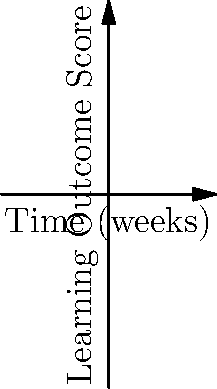Based on the graph comparing learning outcomes of 2D and 3D molecular modeling simulations over time, after 8 weeks of use, what is the approximate difference in learning outcome scores between the two simulation types? How might this inform the implementation of virtual simulations in science education? To answer this question, we need to follow these steps:

1. Identify the lines representing 2D and 3D simulations:
   - Blue line represents 2D simulation
   - Red line represents 3D simulation

2. Locate the 8-week mark on the x-axis (Time).

3. Find the corresponding y-values (Learning Outcome Scores) for both simulations at 8 weeks:
   - For 2D simulation (blue line): approximately 4.8
   - For 3D simulation (red line): approximately 7.2

4. Calculate the difference between the two scores:
   $7.2 - 4.8 = 2.4$

5. Interpret the results:
   The 3D simulation shows a higher learning outcome score by approximately 2.4 points after 8 weeks of use.

6. Consider the implications for implementing virtual simulations in science education:
   - 3D simulations appear to lead to better learning outcomes over time
   - The steeper slope of the 3D simulation line suggests faster learning progression
   - However, factors such as cost, accessibility, and ease of use should also be considered when deciding between 2D and 3D simulations
   - The choice between 2D and 3D simulations may depend on specific learning objectives, available resources, and the target audience
Answer: 2.4 points difference; 3D simulations show better learning outcomes but implementation should consider factors like cost, accessibility, and specific educational goals. 